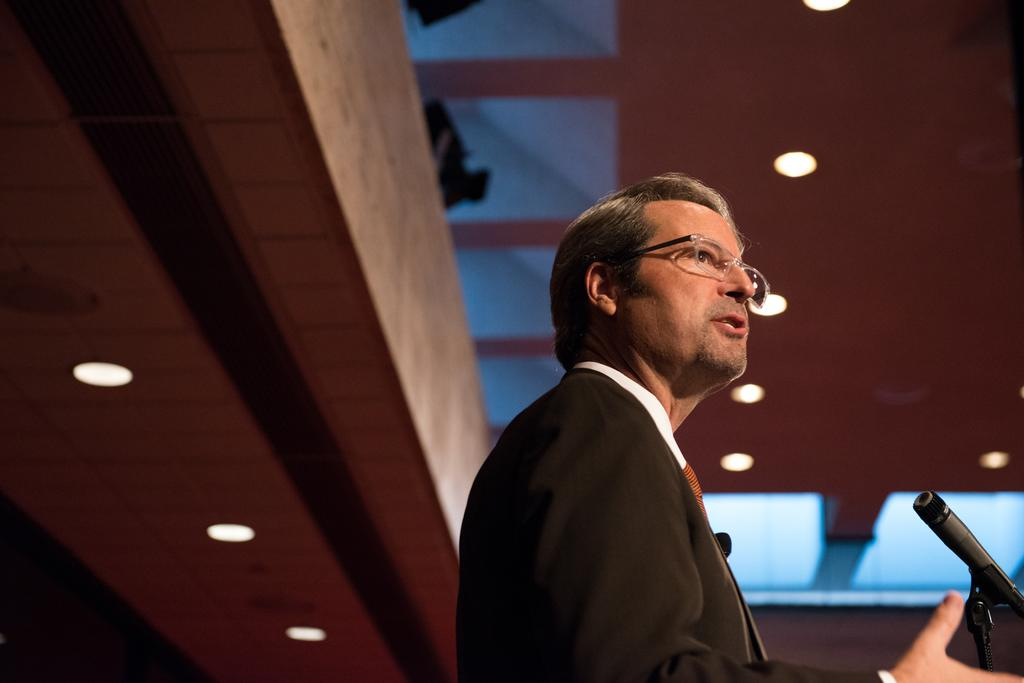What is the main subject of the image? There is a man standing in the image. What object is visible near the man? There is a microphone (mike) in the image. What type of lighting is present in the image? There are ceiling lights in the image. How are the ceiling lights positioned in the image? The ceiling lights are attached to the ceiling. What advice does the man give to the person on their journey in the image? There is no indication in the image that the man is giving advice or that there is a journey taking place. 